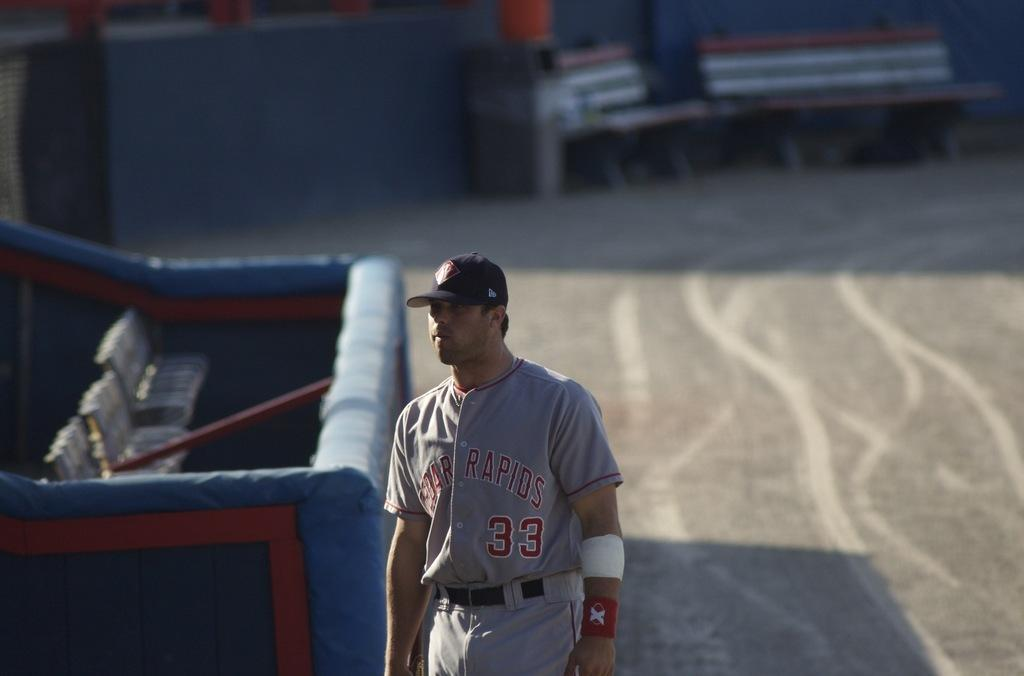<image>
Give a short and clear explanation of the subsequent image. A man wearing a Cedar Rapids baseball jersey walks by the stands. 